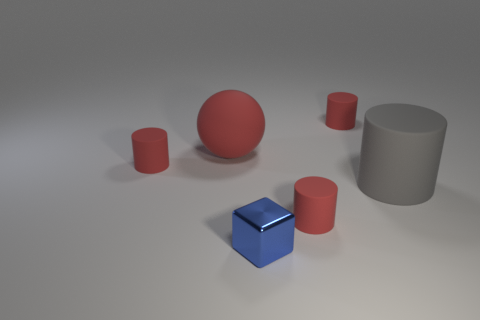What material is the large thing on the left side of the small red matte cylinder behind the large object to the left of the block?
Ensure brevity in your answer.  Rubber. Does the block have the same color as the tiny matte cylinder that is in front of the big gray cylinder?
Make the answer very short. No. Is there any other thing that is the same shape as the small blue shiny thing?
Offer a terse response. No. There is a tiny matte object that is behind the tiny rubber cylinder that is to the left of the tiny blue thing; what is its color?
Your response must be concise. Red. What number of red cylinders are there?
Keep it short and to the point. 3. How many metallic objects are large cylinders or large red spheres?
Provide a succinct answer. 0. What number of big spheres have the same color as the big rubber cylinder?
Your answer should be compact. 0. What is the cylinder that is on the right side of the tiny red object that is behind the red matte sphere made of?
Provide a short and direct response. Rubber. The metal block has what size?
Provide a short and direct response. Small. How many metal blocks are the same size as the blue metal thing?
Keep it short and to the point. 0. 